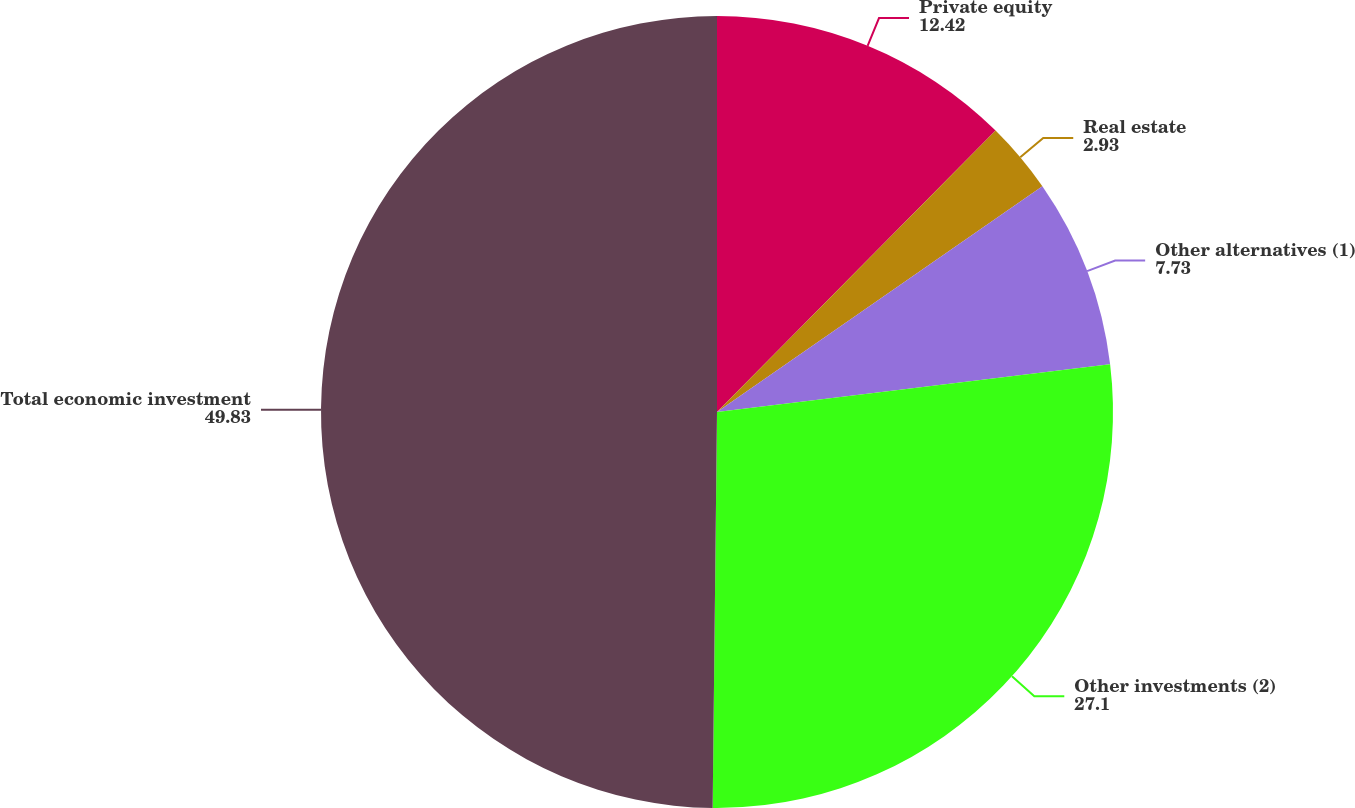Convert chart. <chart><loc_0><loc_0><loc_500><loc_500><pie_chart><fcel>Private equity<fcel>Real estate<fcel>Other alternatives (1)<fcel>Other investments (2)<fcel>Total economic investment<nl><fcel>12.42%<fcel>2.93%<fcel>7.73%<fcel>27.1%<fcel>49.83%<nl></chart> 